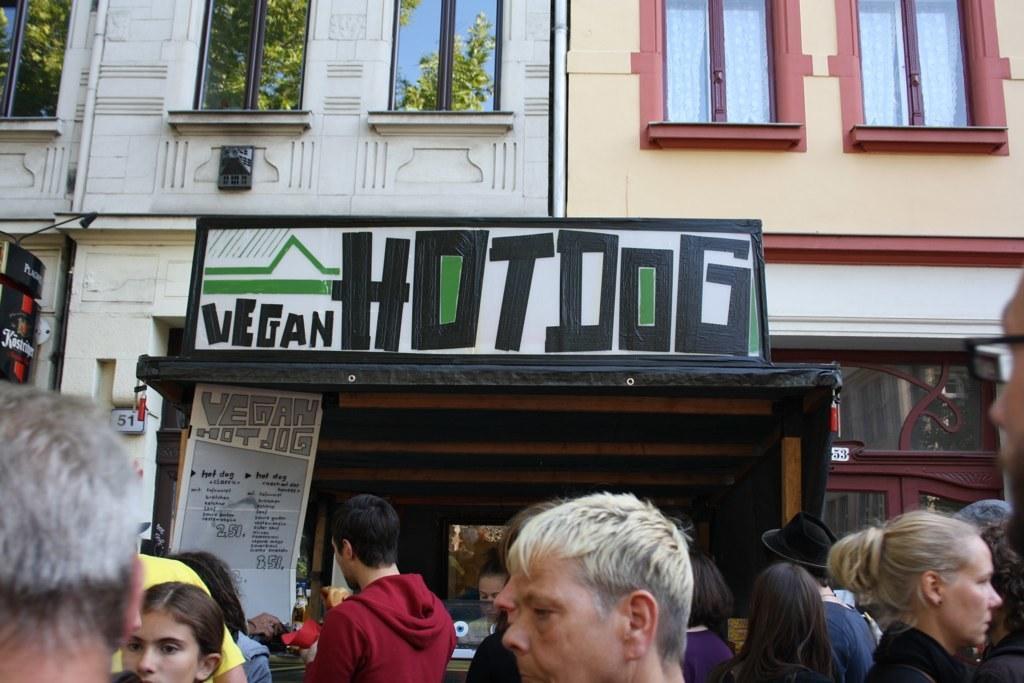Please provide a concise description of this image. At the bottom of the image we can see persons. In the center of the image we can see name board to the building. In the background we can see windows and buildings. 